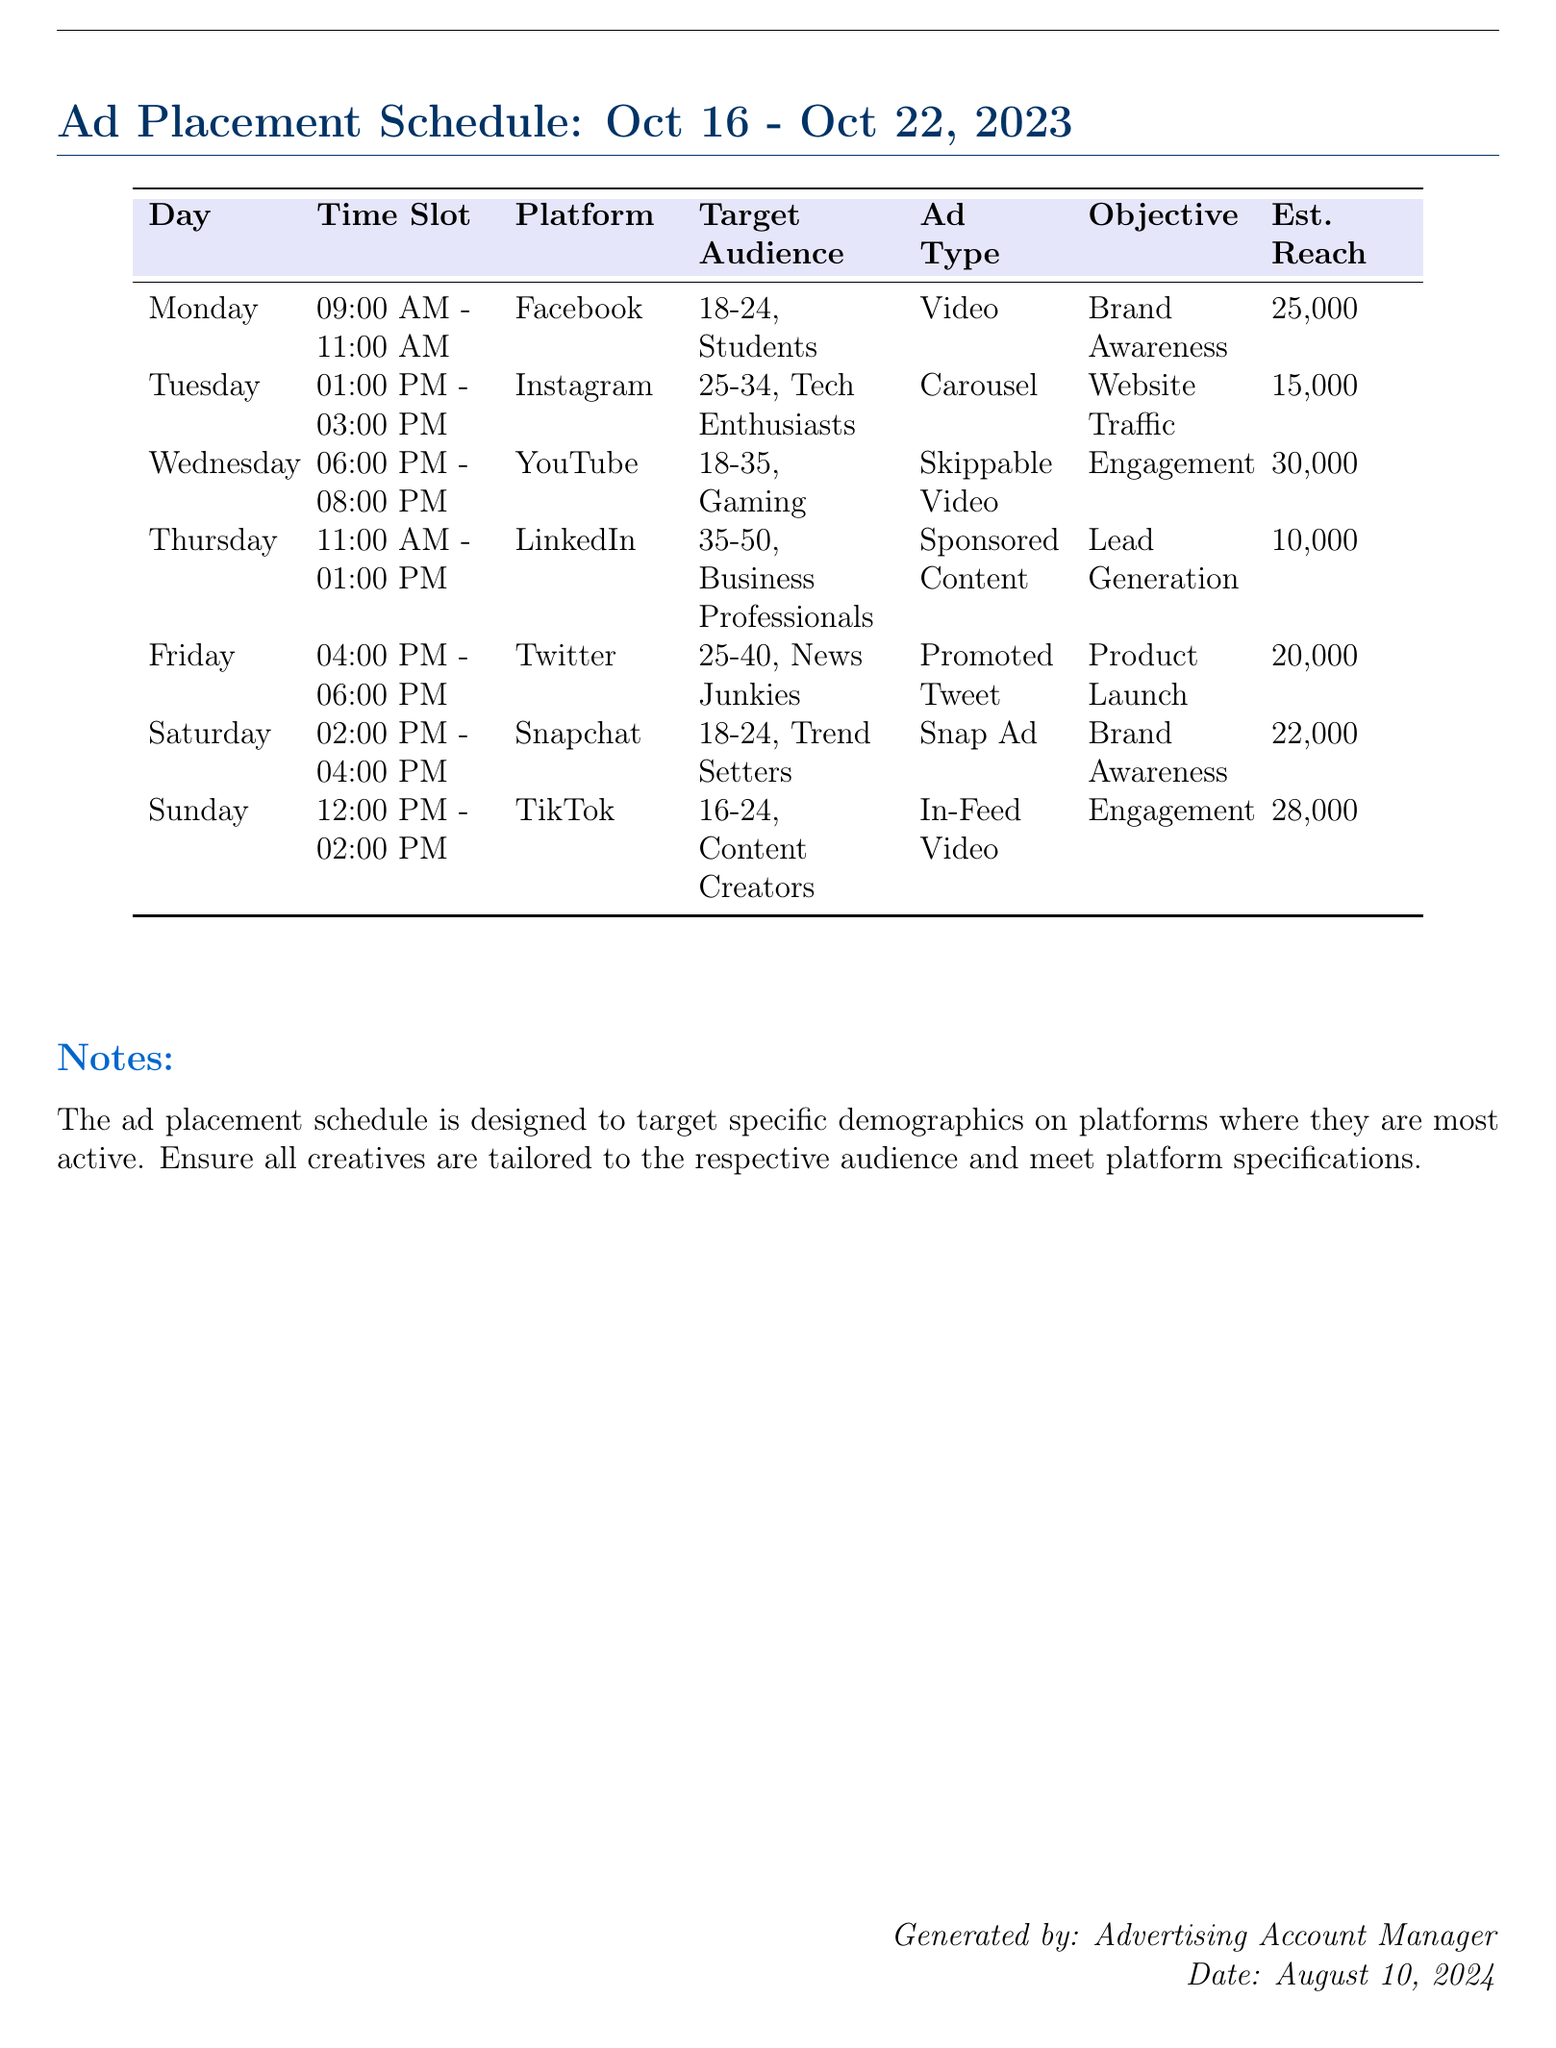What is the ad type for the placement on Monday? The ad type for Monday is specified in the table under the Ad Type column, which is Video.
Answer: Video What is the estimated reach for the Twitter ad on Friday? The estimated reach is stated in the table under the Est. Reach column for Friday, which is 20,000.
Answer: 20,000 Which platform is targeted on Wednesday from 6 PM to 8 PM? The platform for Wednesday's time slot is found in the respective row in the table, which is YouTube.
Answer: YouTube What is the target audience for the Snapchat ad on Saturday? The target audience is detailed in the table under the Target Audience column for Saturday's placement, which is 18-24, Trend Setters.
Answer: 18-24, Trend Setters How many total days are included in the ad placement schedule? The document lists the schedule starting from Monday to Sunday, totaling 7 days.
Answer: 7 days Which day has an ad targeting Business Professionals? The day targeting Business Professionals is located in the table, which is Thursday.
Answer: Thursday What is the objective for the Instagram placement on Tuesday? The objective is specified in the table under the Objective column for Tuesday, which is Website Traffic.
Answer: Website Traffic Which ad type is used for the TikTok placement on Sunday? The ad type is listed in the table for Sunday under the Ad Type column, which is In-Feed Video.
Answer: In-Feed Video What time is the ad on LinkedIn scheduled for Thursday? The scheduled time for Thursday's ad is found in the table under Time Slot, which is 11:00 AM - 01:00 PM.
Answer: 11:00 AM - 01:00 PM 